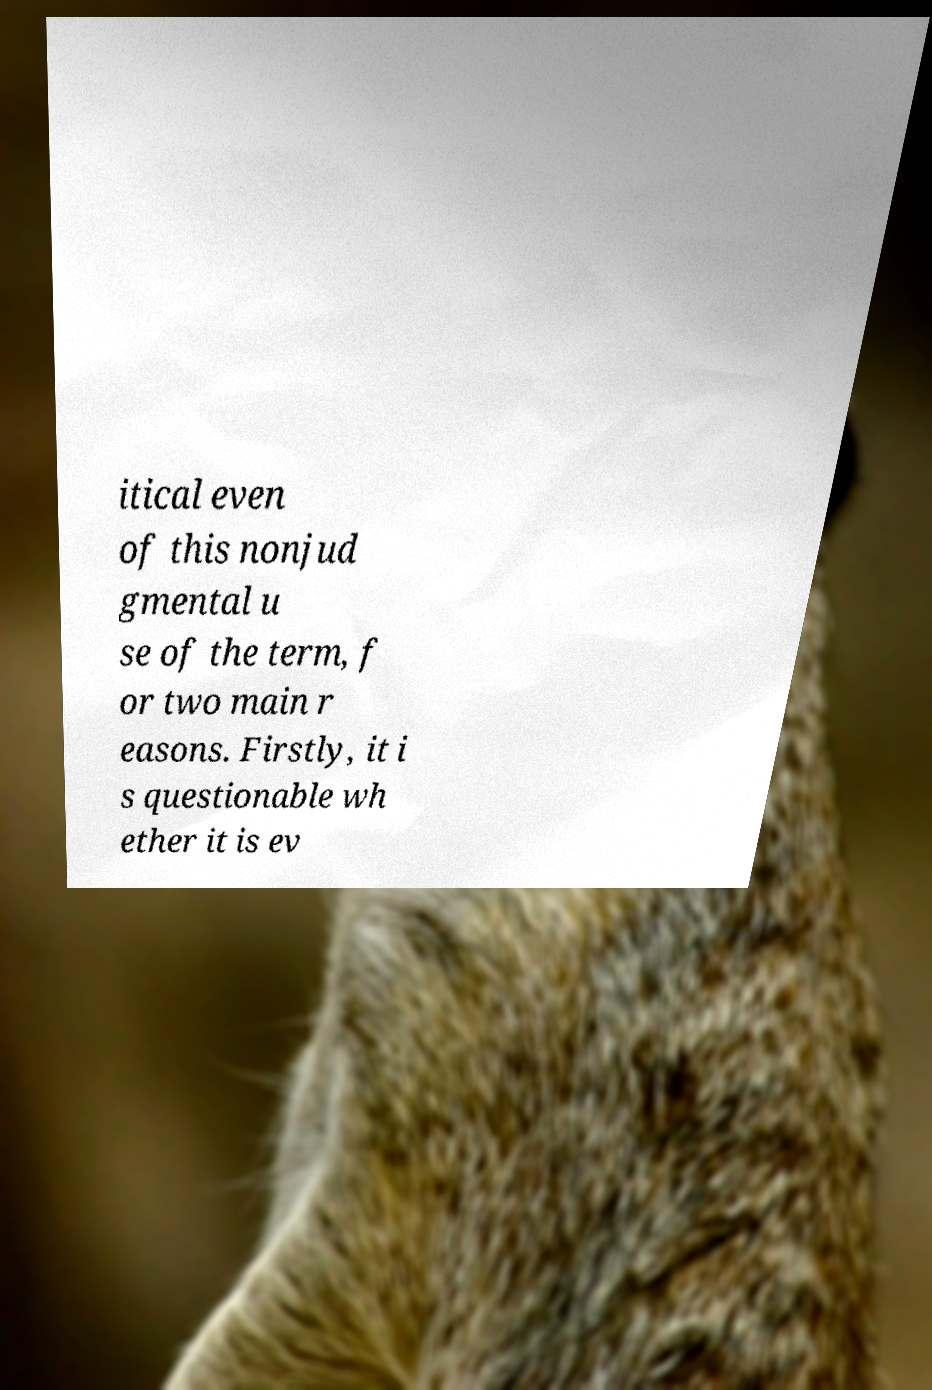Could you assist in decoding the text presented in this image and type it out clearly? itical even of this nonjud gmental u se of the term, f or two main r easons. Firstly, it i s questionable wh ether it is ev 